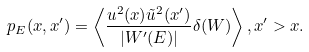<formula> <loc_0><loc_0><loc_500><loc_500>p _ { E } ( x , x ^ { \prime } ) = \left \langle \frac { u ^ { 2 } ( x ) \tilde { u } ^ { 2 } ( x ^ { \prime } ) } { | W ^ { \prime } ( E ) | } \delta ( W ) \right \rangle , x ^ { \prime } > x .</formula> 